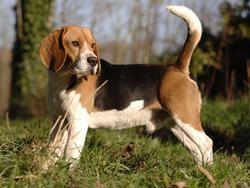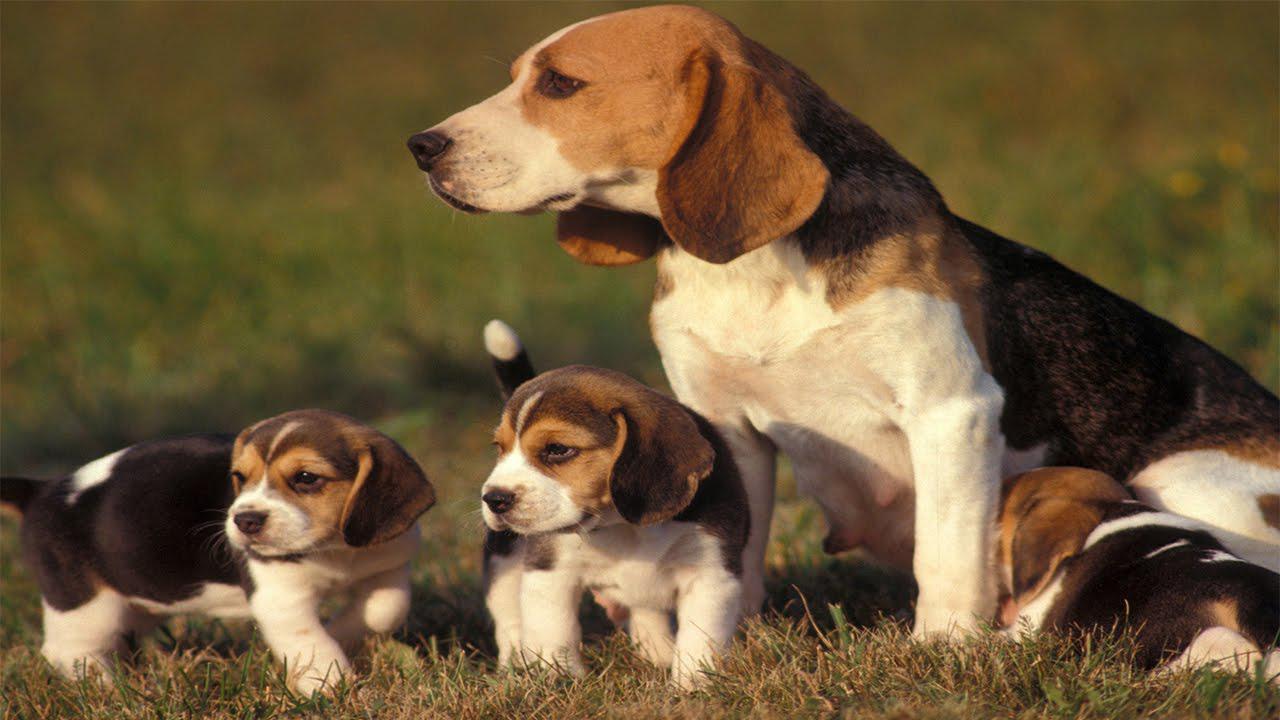The first image is the image on the left, the second image is the image on the right. Examine the images to the left and right. Is the description "All the dogs are lying down." accurate? Answer yes or no. No. 